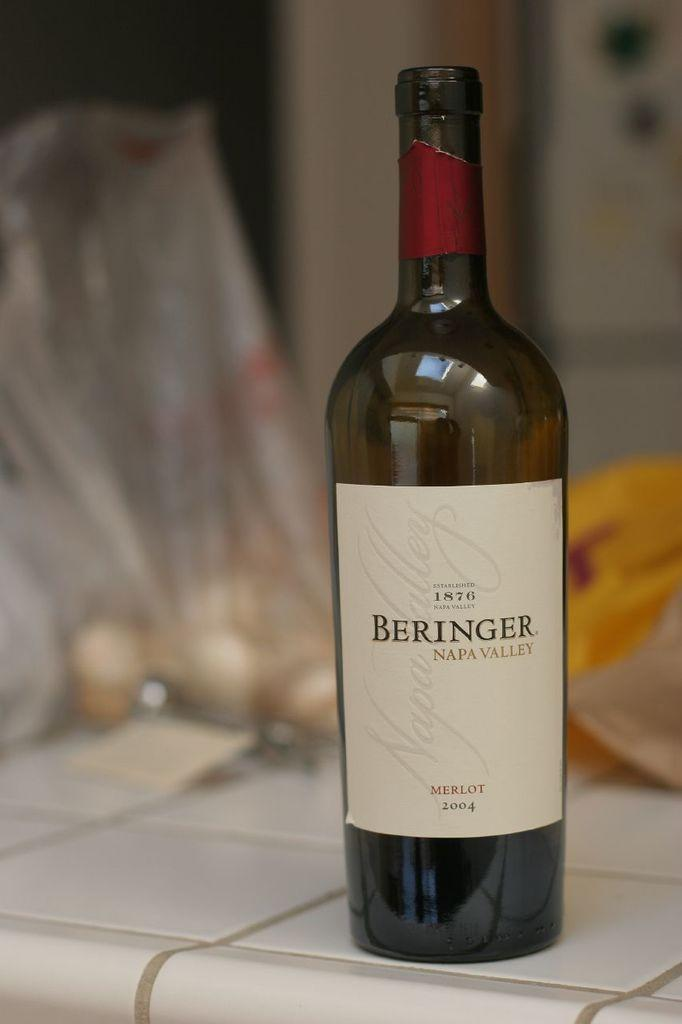<image>
Render a clear and concise summary of the photo. A bottle of wine that has Beringer Napa Valley on the label. 